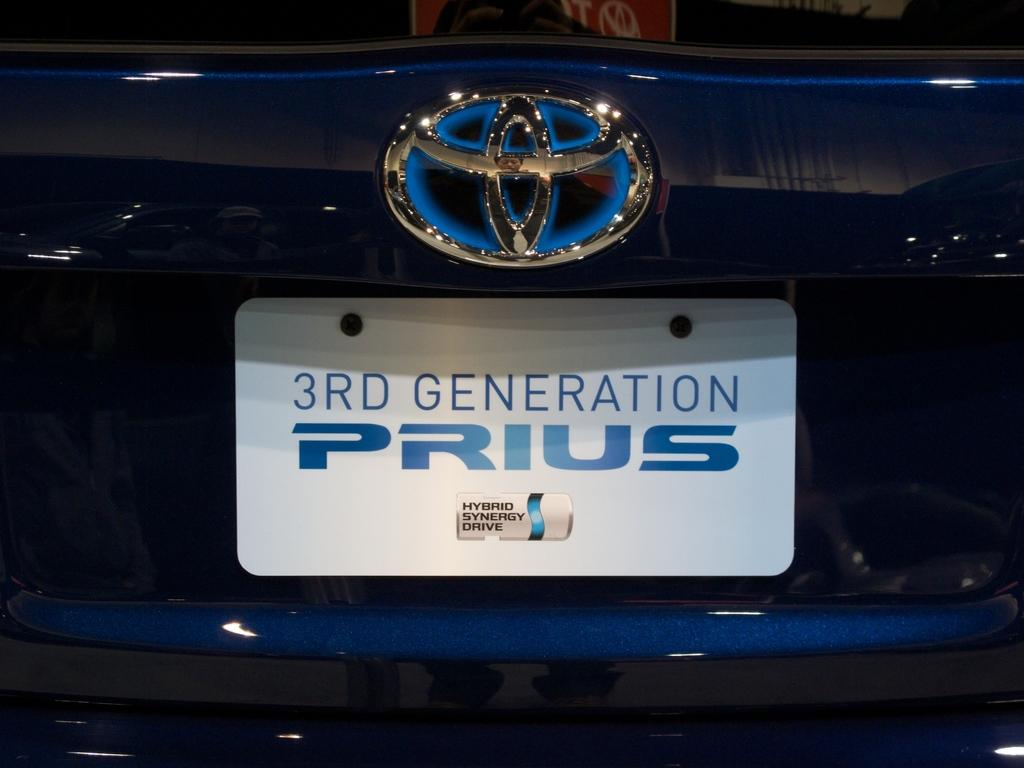<image>
Present a compact description of the photo's key features. the emblem and licences plate of a toyota prius. 